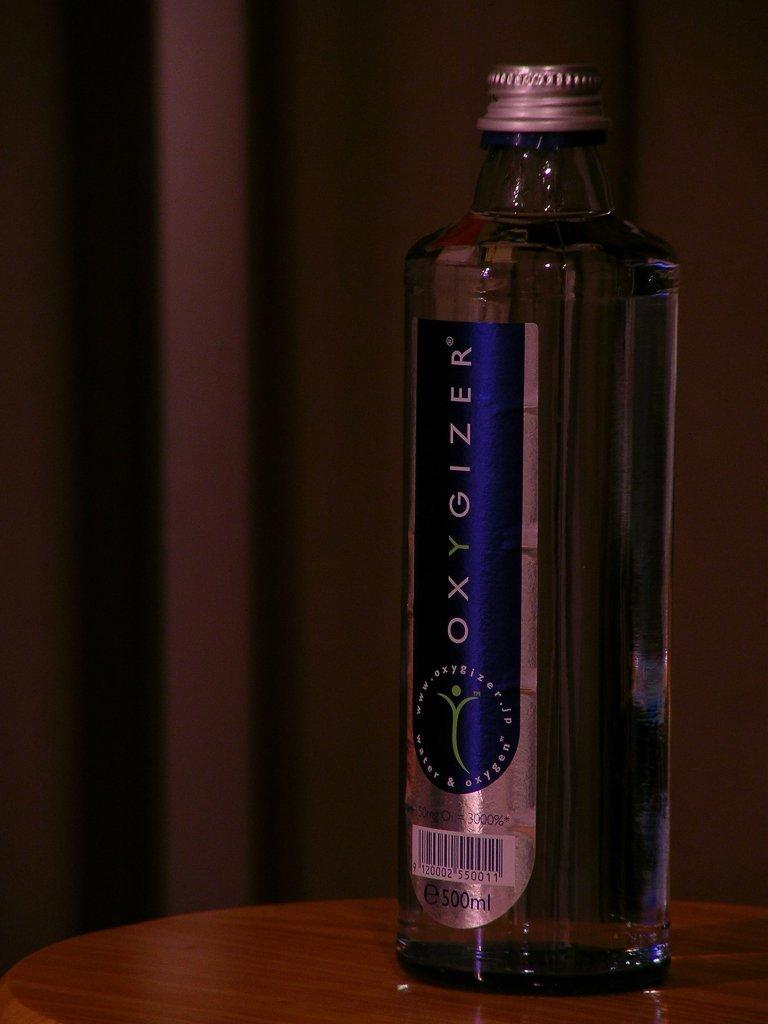Provide a one-sentence caption for the provided image. a bottle of 500 ml Oxygizer filled with water and oxegyn. 